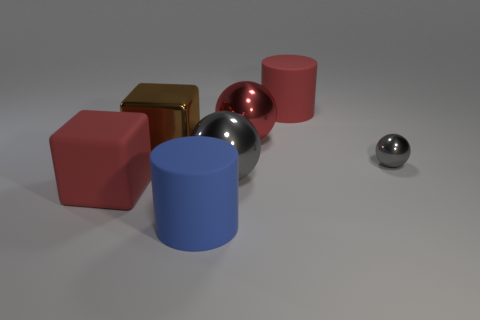Add 1 big brown cubes. How many objects exist? 8 Subtract all spheres. How many objects are left? 4 Subtract 1 blue cylinders. How many objects are left? 6 Subtract all big gray shiny spheres. Subtract all large red spheres. How many objects are left? 5 Add 2 large brown cubes. How many large brown cubes are left? 3 Add 1 big blue cylinders. How many big blue cylinders exist? 2 